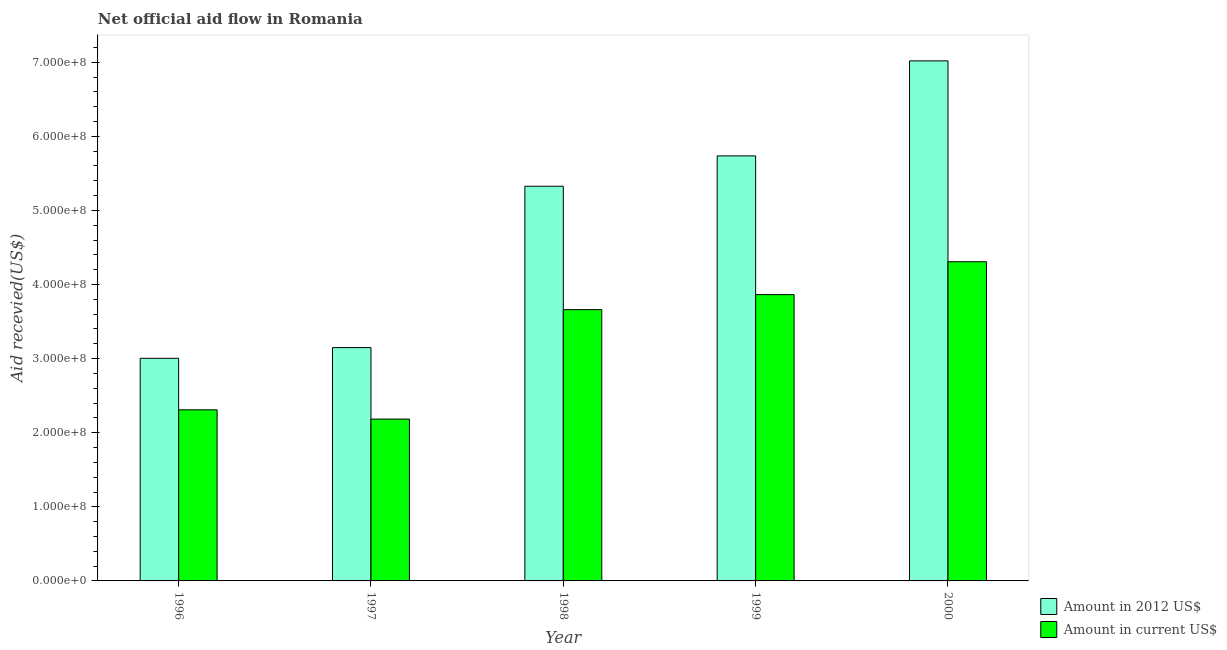How many groups of bars are there?
Offer a terse response. 5. Are the number of bars per tick equal to the number of legend labels?
Your answer should be compact. Yes. Are the number of bars on each tick of the X-axis equal?
Your answer should be very brief. Yes. How many bars are there on the 4th tick from the right?
Your answer should be very brief. 2. What is the label of the 3rd group of bars from the left?
Your answer should be very brief. 1998. In how many cases, is the number of bars for a given year not equal to the number of legend labels?
Give a very brief answer. 0. What is the amount of aid received(expressed in 2012 us$) in 2000?
Make the answer very short. 7.02e+08. Across all years, what is the maximum amount of aid received(expressed in 2012 us$)?
Keep it short and to the point. 7.02e+08. Across all years, what is the minimum amount of aid received(expressed in us$)?
Your response must be concise. 2.18e+08. In which year was the amount of aid received(expressed in us$) minimum?
Your response must be concise. 1997. What is the total amount of aid received(expressed in 2012 us$) in the graph?
Provide a succinct answer. 2.42e+09. What is the difference between the amount of aid received(expressed in us$) in 1998 and that in 1999?
Offer a terse response. -2.03e+07. What is the difference between the amount of aid received(expressed in 2012 us$) in 2000 and the amount of aid received(expressed in us$) in 1998?
Make the answer very short. 1.69e+08. What is the average amount of aid received(expressed in us$) per year?
Make the answer very short. 3.27e+08. In the year 1998, what is the difference between the amount of aid received(expressed in us$) and amount of aid received(expressed in 2012 us$)?
Provide a succinct answer. 0. In how many years, is the amount of aid received(expressed in us$) greater than 480000000 US$?
Ensure brevity in your answer.  0. What is the ratio of the amount of aid received(expressed in 2012 us$) in 1998 to that in 2000?
Your answer should be compact. 0.76. Is the amount of aid received(expressed in us$) in 1997 less than that in 1999?
Keep it short and to the point. Yes. What is the difference between the highest and the second highest amount of aid received(expressed in 2012 us$)?
Ensure brevity in your answer.  1.28e+08. What is the difference between the highest and the lowest amount of aid received(expressed in us$)?
Ensure brevity in your answer.  2.12e+08. What does the 2nd bar from the left in 1996 represents?
Ensure brevity in your answer.  Amount in current US$. What does the 1st bar from the right in 1997 represents?
Ensure brevity in your answer.  Amount in current US$. How many bars are there?
Offer a very short reply. 10. Are all the bars in the graph horizontal?
Make the answer very short. No. What is the difference between two consecutive major ticks on the Y-axis?
Offer a terse response. 1.00e+08. Are the values on the major ticks of Y-axis written in scientific E-notation?
Ensure brevity in your answer.  Yes. Does the graph contain any zero values?
Ensure brevity in your answer.  No. Does the graph contain grids?
Offer a very short reply. No. How are the legend labels stacked?
Your answer should be very brief. Vertical. What is the title of the graph?
Keep it short and to the point. Net official aid flow in Romania. Does "Goods" appear as one of the legend labels in the graph?
Keep it short and to the point. No. What is the label or title of the Y-axis?
Keep it short and to the point. Aid recevied(US$). What is the Aid recevied(US$) in Amount in 2012 US$ in 1996?
Give a very brief answer. 3.00e+08. What is the Aid recevied(US$) in Amount in current US$ in 1996?
Provide a short and direct response. 2.31e+08. What is the Aid recevied(US$) in Amount in 2012 US$ in 1997?
Your response must be concise. 3.15e+08. What is the Aid recevied(US$) of Amount in current US$ in 1997?
Keep it short and to the point. 2.18e+08. What is the Aid recevied(US$) of Amount in 2012 US$ in 1998?
Provide a succinct answer. 5.33e+08. What is the Aid recevied(US$) of Amount in current US$ in 1998?
Give a very brief answer. 3.66e+08. What is the Aid recevied(US$) of Amount in 2012 US$ in 1999?
Provide a succinct answer. 5.74e+08. What is the Aid recevied(US$) of Amount in current US$ in 1999?
Your answer should be compact. 3.86e+08. What is the Aid recevied(US$) in Amount in 2012 US$ in 2000?
Offer a very short reply. 7.02e+08. What is the Aid recevied(US$) of Amount in current US$ in 2000?
Offer a terse response. 4.31e+08. Across all years, what is the maximum Aid recevied(US$) in Amount in 2012 US$?
Provide a short and direct response. 7.02e+08. Across all years, what is the maximum Aid recevied(US$) in Amount in current US$?
Your answer should be compact. 4.31e+08. Across all years, what is the minimum Aid recevied(US$) in Amount in 2012 US$?
Ensure brevity in your answer.  3.00e+08. Across all years, what is the minimum Aid recevied(US$) in Amount in current US$?
Your answer should be very brief. 2.18e+08. What is the total Aid recevied(US$) in Amount in 2012 US$ in the graph?
Offer a very short reply. 2.42e+09. What is the total Aid recevied(US$) of Amount in current US$ in the graph?
Your answer should be very brief. 1.63e+09. What is the difference between the Aid recevied(US$) of Amount in 2012 US$ in 1996 and that in 1997?
Make the answer very short. -1.44e+07. What is the difference between the Aid recevied(US$) in Amount in current US$ in 1996 and that in 1997?
Your answer should be very brief. 1.25e+07. What is the difference between the Aid recevied(US$) in Amount in 2012 US$ in 1996 and that in 1998?
Ensure brevity in your answer.  -2.32e+08. What is the difference between the Aid recevied(US$) in Amount in current US$ in 1996 and that in 1998?
Your response must be concise. -1.35e+08. What is the difference between the Aid recevied(US$) in Amount in 2012 US$ in 1996 and that in 1999?
Your response must be concise. -2.73e+08. What is the difference between the Aid recevied(US$) of Amount in current US$ in 1996 and that in 1999?
Offer a terse response. -1.55e+08. What is the difference between the Aid recevied(US$) in Amount in 2012 US$ in 1996 and that in 2000?
Provide a succinct answer. -4.01e+08. What is the difference between the Aid recevied(US$) of Amount in current US$ in 1996 and that in 2000?
Your answer should be very brief. -2.00e+08. What is the difference between the Aid recevied(US$) in Amount in 2012 US$ in 1997 and that in 1998?
Your response must be concise. -2.18e+08. What is the difference between the Aid recevied(US$) of Amount in current US$ in 1997 and that in 1998?
Make the answer very short. -1.48e+08. What is the difference between the Aid recevied(US$) of Amount in 2012 US$ in 1997 and that in 1999?
Ensure brevity in your answer.  -2.59e+08. What is the difference between the Aid recevied(US$) of Amount in current US$ in 1997 and that in 1999?
Give a very brief answer. -1.68e+08. What is the difference between the Aid recevied(US$) of Amount in 2012 US$ in 1997 and that in 2000?
Your answer should be compact. -3.87e+08. What is the difference between the Aid recevied(US$) in Amount in current US$ in 1997 and that in 2000?
Your answer should be very brief. -2.12e+08. What is the difference between the Aid recevied(US$) of Amount in 2012 US$ in 1998 and that in 1999?
Keep it short and to the point. -4.10e+07. What is the difference between the Aid recevied(US$) of Amount in current US$ in 1998 and that in 1999?
Provide a short and direct response. -2.03e+07. What is the difference between the Aid recevied(US$) in Amount in 2012 US$ in 1998 and that in 2000?
Your answer should be very brief. -1.69e+08. What is the difference between the Aid recevied(US$) in Amount in current US$ in 1998 and that in 2000?
Provide a succinct answer. -6.46e+07. What is the difference between the Aid recevied(US$) of Amount in 2012 US$ in 1999 and that in 2000?
Make the answer very short. -1.28e+08. What is the difference between the Aid recevied(US$) in Amount in current US$ in 1999 and that in 2000?
Provide a short and direct response. -4.44e+07. What is the difference between the Aid recevied(US$) in Amount in 2012 US$ in 1996 and the Aid recevied(US$) in Amount in current US$ in 1997?
Keep it short and to the point. 8.20e+07. What is the difference between the Aid recevied(US$) of Amount in 2012 US$ in 1996 and the Aid recevied(US$) of Amount in current US$ in 1998?
Offer a very short reply. -6.57e+07. What is the difference between the Aid recevied(US$) in Amount in 2012 US$ in 1996 and the Aid recevied(US$) in Amount in current US$ in 1999?
Make the answer very short. -8.59e+07. What is the difference between the Aid recevied(US$) in Amount in 2012 US$ in 1996 and the Aid recevied(US$) in Amount in current US$ in 2000?
Your answer should be compact. -1.30e+08. What is the difference between the Aid recevied(US$) of Amount in 2012 US$ in 1997 and the Aid recevied(US$) of Amount in current US$ in 1998?
Make the answer very short. -5.13e+07. What is the difference between the Aid recevied(US$) in Amount in 2012 US$ in 1997 and the Aid recevied(US$) in Amount in current US$ in 1999?
Offer a terse response. -7.15e+07. What is the difference between the Aid recevied(US$) in Amount in 2012 US$ in 1997 and the Aid recevied(US$) in Amount in current US$ in 2000?
Ensure brevity in your answer.  -1.16e+08. What is the difference between the Aid recevied(US$) in Amount in 2012 US$ in 1998 and the Aid recevied(US$) in Amount in current US$ in 1999?
Your response must be concise. 1.46e+08. What is the difference between the Aid recevied(US$) in Amount in 2012 US$ in 1998 and the Aid recevied(US$) in Amount in current US$ in 2000?
Offer a terse response. 1.02e+08. What is the difference between the Aid recevied(US$) in Amount in 2012 US$ in 1999 and the Aid recevied(US$) in Amount in current US$ in 2000?
Provide a short and direct response. 1.43e+08. What is the average Aid recevied(US$) of Amount in 2012 US$ per year?
Make the answer very short. 4.85e+08. What is the average Aid recevied(US$) in Amount in current US$ per year?
Provide a succinct answer. 3.27e+08. In the year 1996, what is the difference between the Aid recevied(US$) in Amount in 2012 US$ and Aid recevied(US$) in Amount in current US$?
Provide a short and direct response. 6.95e+07. In the year 1997, what is the difference between the Aid recevied(US$) of Amount in 2012 US$ and Aid recevied(US$) of Amount in current US$?
Provide a succinct answer. 9.64e+07. In the year 1998, what is the difference between the Aid recevied(US$) in Amount in 2012 US$ and Aid recevied(US$) in Amount in current US$?
Ensure brevity in your answer.  1.67e+08. In the year 1999, what is the difference between the Aid recevied(US$) of Amount in 2012 US$ and Aid recevied(US$) of Amount in current US$?
Offer a terse response. 1.87e+08. In the year 2000, what is the difference between the Aid recevied(US$) in Amount in 2012 US$ and Aid recevied(US$) in Amount in current US$?
Provide a succinct answer. 2.71e+08. What is the ratio of the Aid recevied(US$) in Amount in 2012 US$ in 1996 to that in 1997?
Keep it short and to the point. 0.95. What is the ratio of the Aid recevied(US$) in Amount in current US$ in 1996 to that in 1997?
Your answer should be very brief. 1.06. What is the ratio of the Aid recevied(US$) in Amount in 2012 US$ in 1996 to that in 1998?
Give a very brief answer. 0.56. What is the ratio of the Aid recevied(US$) in Amount in current US$ in 1996 to that in 1998?
Your response must be concise. 0.63. What is the ratio of the Aid recevied(US$) of Amount in 2012 US$ in 1996 to that in 1999?
Provide a succinct answer. 0.52. What is the ratio of the Aid recevied(US$) of Amount in current US$ in 1996 to that in 1999?
Ensure brevity in your answer.  0.6. What is the ratio of the Aid recevied(US$) in Amount in 2012 US$ in 1996 to that in 2000?
Make the answer very short. 0.43. What is the ratio of the Aid recevied(US$) of Amount in current US$ in 1996 to that in 2000?
Provide a succinct answer. 0.54. What is the ratio of the Aid recevied(US$) in Amount in 2012 US$ in 1997 to that in 1998?
Provide a short and direct response. 0.59. What is the ratio of the Aid recevied(US$) of Amount in current US$ in 1997 to that in 1998?
Offer a very short reply. 0.6. What is the ratio of the Aid recevied(US$) in Amount in 2012 US$ in 1997 to that in 1999?
Make the answer very short. 0.55. What is the ratio of the Aid recevied(US$) of Amount in current US$ in 1997 to that in 1999?
Offer a very short reply. 0.57. What is the ratio of the Aid recevied(US$) of Amount in 2012 US$ in 1997 to that in 2000?
Provide a succinct answer. 0.45. What is the ratio of the Aid recevied(US$) in Amount in current US$ in 1997 to that in 2000?
Make the answer very short. 0.51. What is the ratio of the Aid recevied(US$) of Amount in current US$ in 1998 to that in 1999?
Offer a terse response. 0.95. What is the ratio of the Aid recevied(US$) in Amount in 2012 US$ in 1998 to that in 2000?
Your response must be concise. 0.76. What is the ratio of the Aid recevied(US$) in Amount in current US$ in 1998 to that in 2000?
Ensure brevity in your answer.  0.85. What is the ratio of the Aid recevied(US$) in Amount in 2012 US$ in 1999 to that in 2000?
Ensure brevity in your answer.  0.82. What is the ratio of the Aid recevied(US$) in Amount in current US$ in 1999 to that in 2000?
Provide a short and direct response. 0.9. What is the difference between the highest and the second highest Aid recevied(US$) of Amount in 2012 US$?
Give a very brief answer. 1.28e+08. What is the difference between the highest and the second highest Aid recevied(US$) in Amount in current US$?
Your answer should be compact. 4.44e+07. What is the difference between the highest and the lowest Aid recevied(US$) in Amount in 2012 US$?
Your answer should be compact. 4.01e+08. What is the difference between the highest and the lowest Aid recevied(US$) in Amount in current US$?
Give a very brief answer. 2.12e+08. 